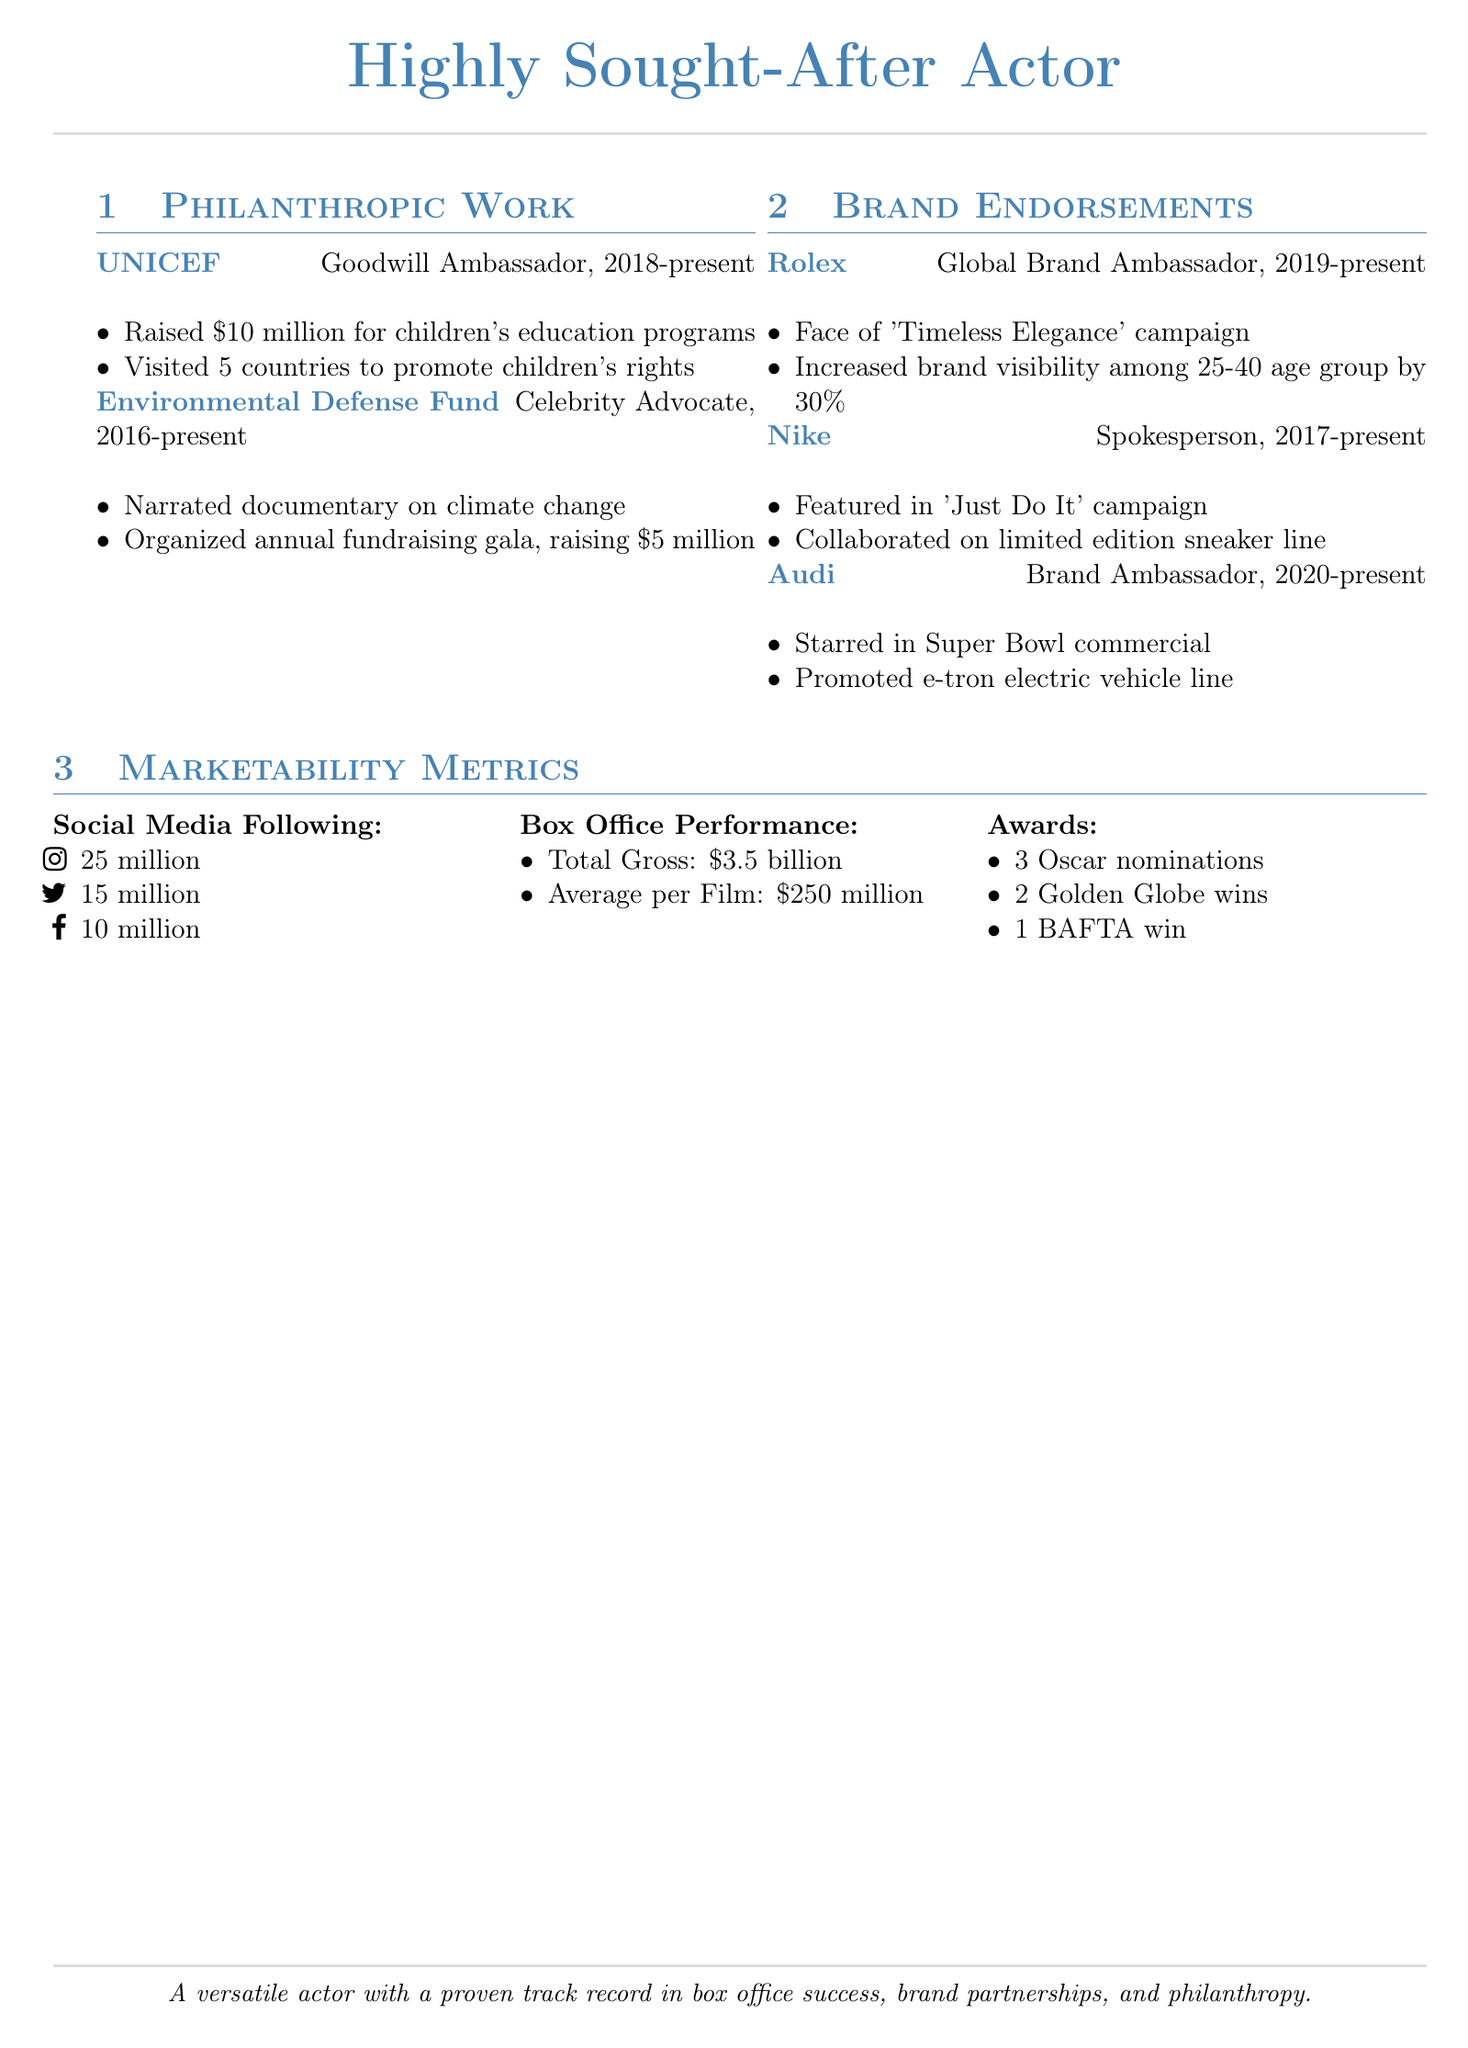what is the role at UNICEF? The role at UNICEF is specified as Goodwill Ambassador.
Answer: Goodwill Ambassador how much money was raised for children's education programs? The document states that $10 million was raised for children's education programs by UNICEF.
Answer: $10 million which organization does the actor serve as a Celebrity Advocate? The document mentions that the actor serves as a Celebrity Advocate for the Environmental Defense Fund.
Answer: Environmental Defense Fund what is the average box office gross per film? The average box office gross per film is mentioned as $250 million in the marketability metrics.
Answer: $250 million how many Oscar nominations has the actor received? The total number of Oscar nominations received is stated as 3 in the awards section.
Answer: 3 what percentage did the Rolex campaign increase brand visibility? The document indicates that the Rolex campaign increased brand visibility by 30%.
Answer: 30% how long has the actor been a Global Brand Ambassador for Rolex? The time period mentioned for being a Global Brand Ambassador for Rolex is from 2019 to present, which is approximately 4 years.
Answer: 4 years which documentary did the actor narrate related to climate change? The document implies that the actor narrated a documentary on climate change for the Environmental Defense Fund.
Answer: documentary on climate change how many social media followers does the actor have on Instagram? The document states that the actor has 25 million followers on Instagram.
Answer: 25 million 